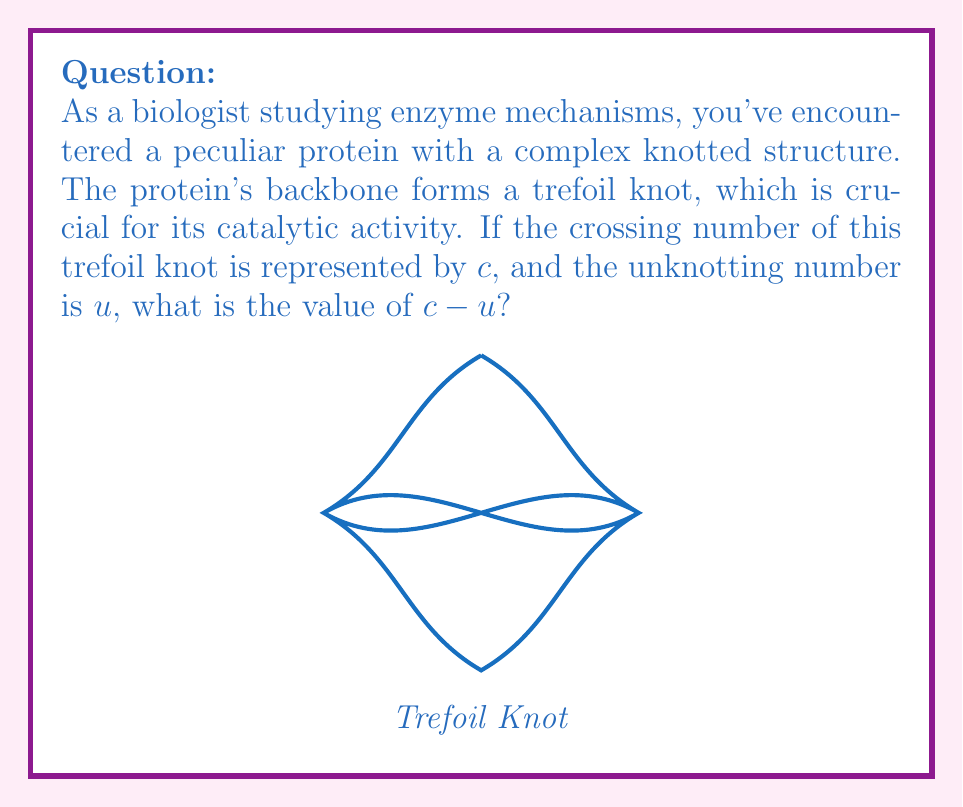Show me your answer to this math problem. Let's approach this step-by-step:

1) First, let's recall what these terms mean in knot theory:
   - The crossing number ($c$) is the minimum number of crossings in any diagram of the knot.
   - The unknotting number ($u$) is the minimum number of crossing changes needed to turn the knot into an unknot.

2) For a trefoil knot:
   - The crossing number $c = 3$. This is the minimum number of crossings possible in any diagram of a trefoil knot.
   - The unknotting number $u = 1$. A single crossing change can turn a trefoil knot into an unknot.

3) Now, we can calculate $c - u$:
   $$c - u = 3 - 1 = 2$$

4) This result, $c - u = 2$, is actually a general property of the trefoil knot and is related to its genus. The genus of a knot is a measure of its complexity, and for the trefoil knot, the genus is 1.

5) In knot theory, there's a relationship between crossing number, unknotting number, and genus ($g$) for alternating knots (which includes the trefoil):
   $$c - u \geq 2g$$

   For the trefoil, this inequality becomes an equality: $3 - 1 = 2(1)$

This problem illustrates how topological properties of knots can be relevant to understanding protein structures, as knotted proteins often have unique functional properties related to their topology.
Answer: 2 